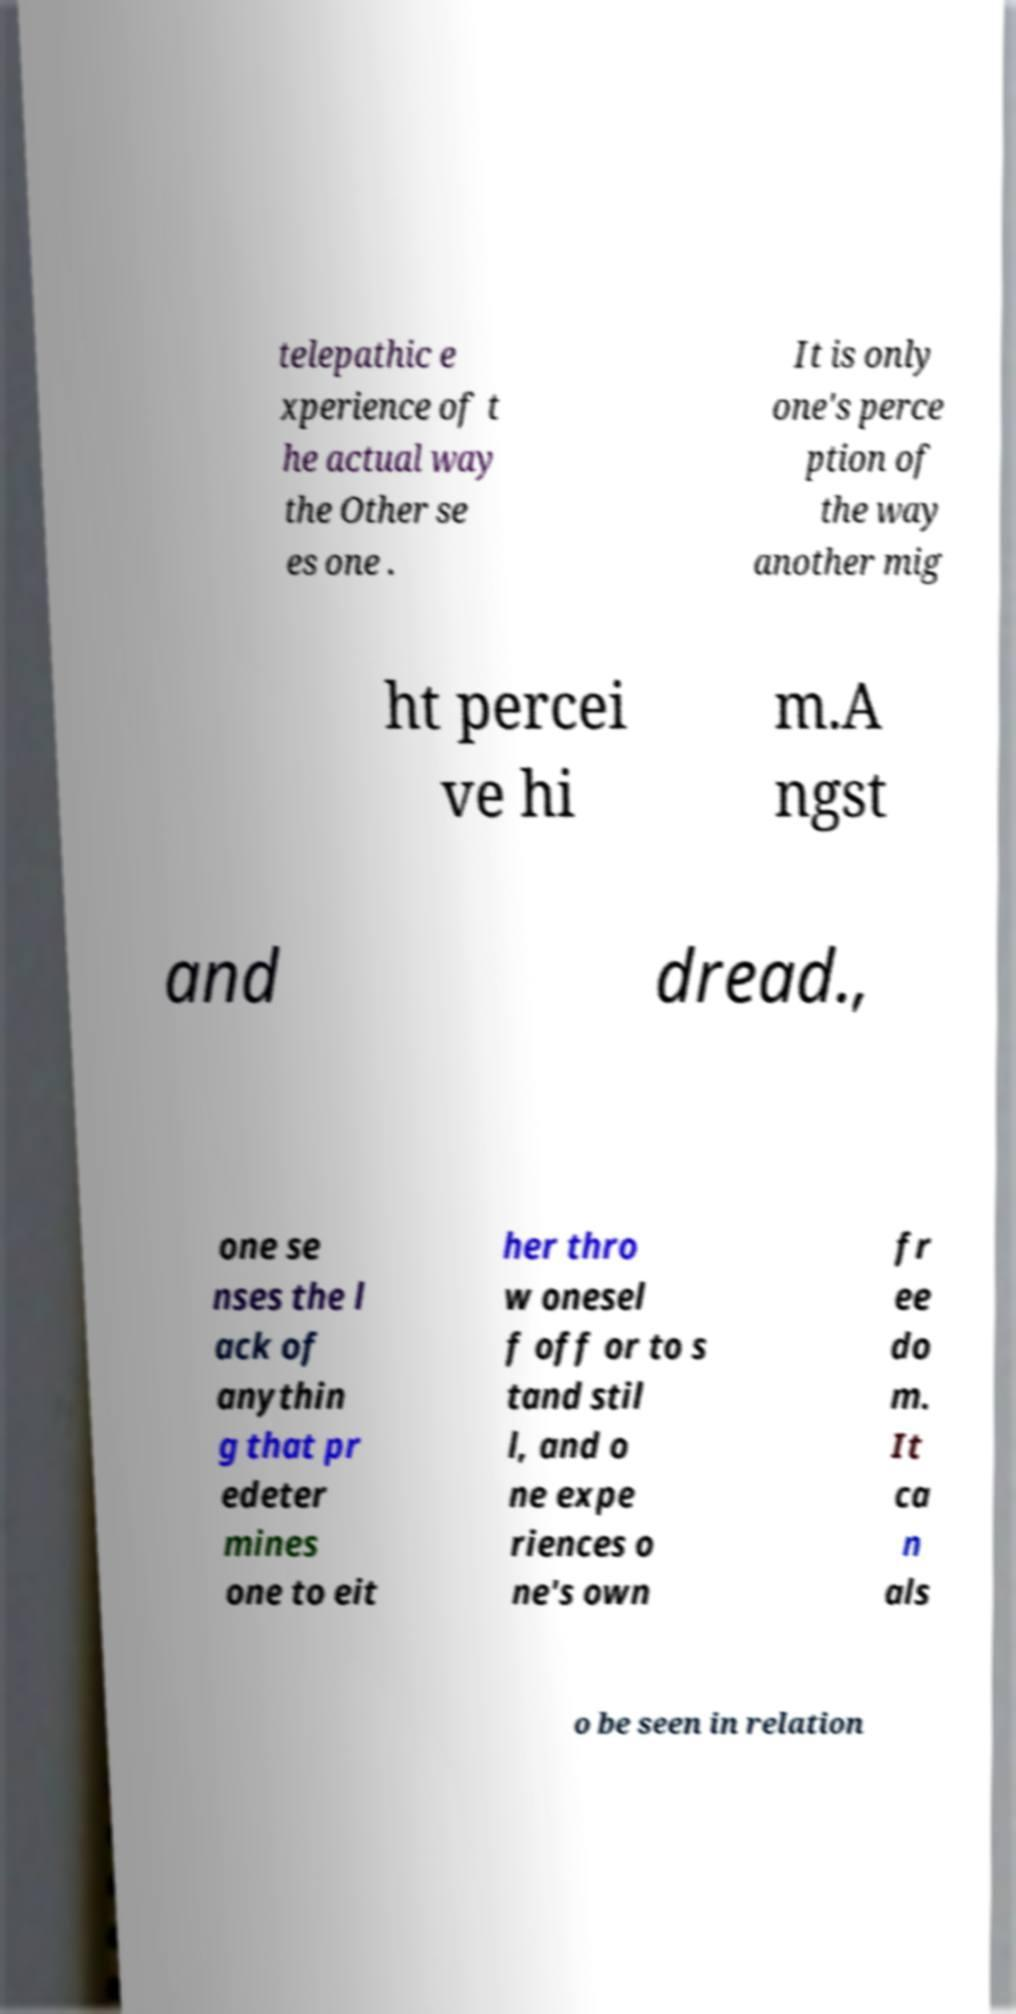Please identify and transcribe the text found in this image. telepathic e xperience of t he actual way the Other se es one . It is only one's perce ption of the way another mig ht percei ve hi m.A ngst and dread., one se nses the l ack of anythin g that pr edeter mines one to eit her thro w onesel f off or to s tand stil l, and o ne expe riences o ne's own fr ee do m. It ca n als o be seen in relation 